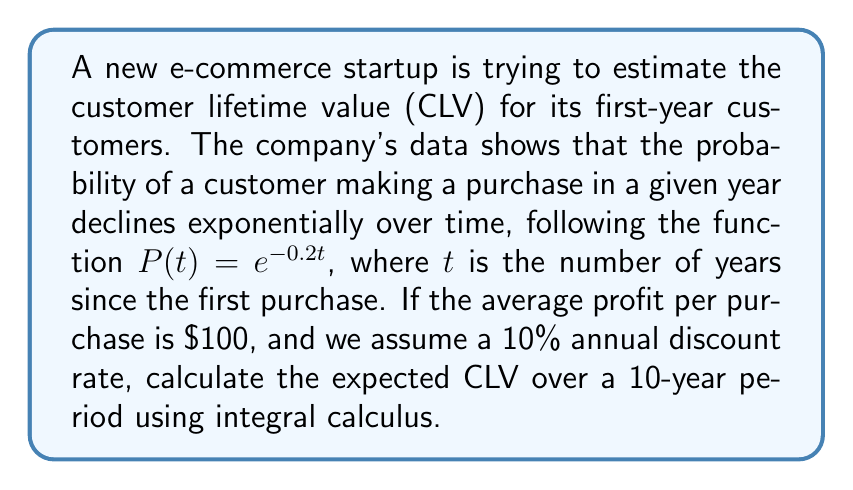Can you answer this question? To solve this problem, we need to use the continuous-time CLV formula, which involves integral calculus and incorporates the probability of purchase over time.

1. The CLV formula in continuous time is given by:

   $$CLV = \int_0^T M(t) \cdot P(t) \cdot e^{-rt} dt$$

   Where:
   - $T$ is the time horizon (10 years in this case)
   - $M(t)$ is the profit per purchase ($100, constant in this case)
   - $P(t)$ is the probability of purchase at time $t$ ($e^{-0.2t}$)
   - $r$ is the discount rate (10% or 0.1)

2. Substituting the given values into the formula:

   $$CLV = \int_0^{10} 100 \cdot e^{-0.2t} \cdot e^{-0.1t} dt$$

3. Simplify the integrand:

   $$CLV = 100 \int_0^{10} e^{-0.3t} dt$$

4. Solve the integral:

   $$CLV = 100 \left[ -\frac{1}{0.3} e^{-0.3t} \right]_0^{10}$$

5. Evaluate the bounds:

   $$CLV = 100 \left( -\frac{1}{0.3} e^{-3} + \frac{1}{0.3} \right)$$

6. Calculate the final result:

   $$CLV = 100 \cdot \frac{1}{0.3} \left( 1 - e^{-3} \right) \approx 316.84$$

Therefore, the expected Customer Lifetime Value over a 10-year period is approximately $316.84.
Answer: $316.84 